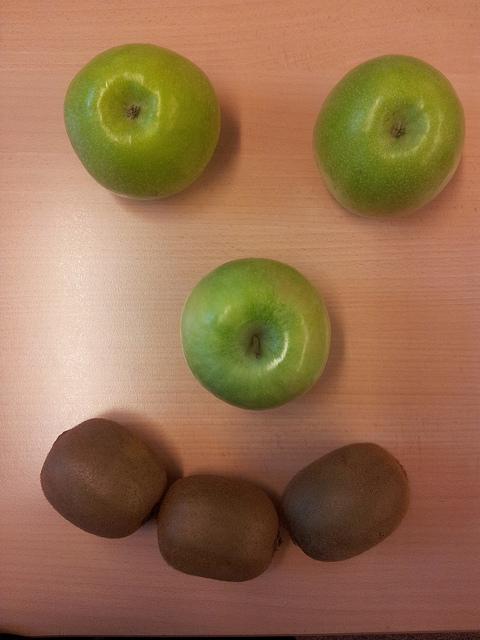What type of fruit is this?
Quick response, please. Apple. How many kiwis are in this photo?
Give a very brief answer. 3. What color is the apple?
Answer briefly. Green. How many apples are there?
Write a very short answer. 3. 